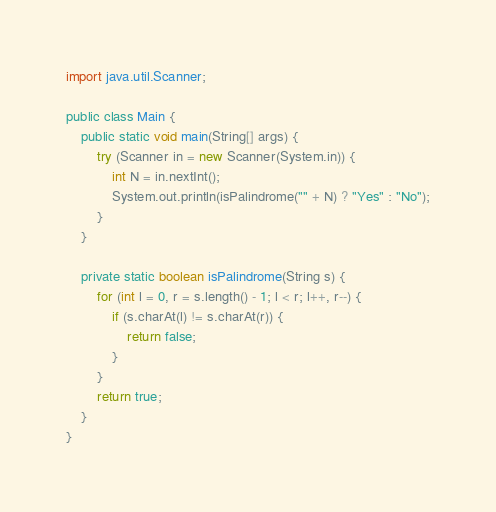Convert code to text. <code><loc_0><loc_0><loc_500><loc_500><_Java_>import java.util.Scanner;

public class Main {
    public static void main(String[] args) {
        try (Scanner in = new Scanner(System.in)) {
            int N = in.nextInt();
            System.out.println(isPalindrome("" + N) ? "Yes" : "No");
        }
    }

    private static boolean isPalindrome(String s) {
        for (int l = 0, r = s.length() - 1; l < r; l++, r--) {
            if (s.charAt(l) != s.charAt(r)) {
                return false;
            }
        }
        return true;
    }
}
</code> 